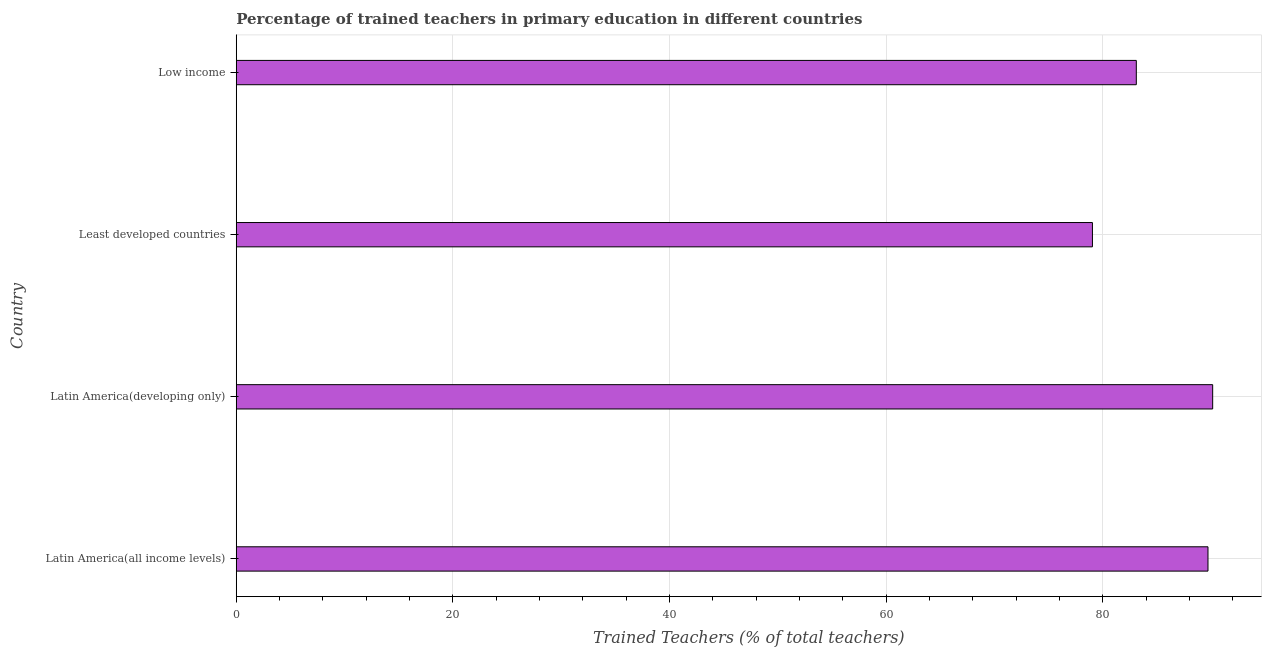Does the graph contain any zero values?
Provide a succinct answer. No. Does the graph contain grids?
Offer a terse response. Yes. What is the title of the graph?
Your answer should be very brief. Percentage of trained teachers in primary education in different countries. What is the label or title of the X-axis?
Your answer should be compact. Trained Teachers (% of total teachers). What is the percentage of trained teachers in Latin America(developing only)?
Keep it short and to the point. 90.13. Across all countries, what is the maximum percentage of trained teachers?
Provide a succinct answer. 90.13. Across all countries, what is the minimum percentage of trained teachers?
Your answer should be very brief. 79.03. In which country was the percentage of trained teachers maximum?
Provide a succinct answer. Latin America(developing only). In which country was the percentage of trained teachers minimum?
Offer a terse response. Least developed countries. What is the sum of the percentage of trained teachers?
Give a very brief answer. 341.94. What is the difference between the percentage of trained teachers in Latin America(developing only) and Least developed countries?
Ensure brevity in your answer.  11.1. What is the average percentage of trained teachers per country?
Provide a succinct answer. 85.48. What is the median percentage of trained teachers?
Your answer should be very brief. 86.39. In how many countries, is the percentage of trained teachers greater than 48 %?
Offer a terse response. 4. What is the ratio of the percentage of trained teachers in Least developed countries to that in Low income?
Offer a terse response. 0.95. What is the difference between the highest and the second highest percentage of trained teachers?
Ensure brevity in your answer.  0.43. Is the sum of the percentage of trained teachers in Latin America(all income levels) and Least developed countries greater than the maximum percentage of trained teachers across all countries?
Your answer should be very brief. Yes. What is the difference between the highest and the lowest percentage of trained teachers?
Offer a very short reply. 11.1. How many bars are there?
Provide a short and direct response. 4. Are all the bars in the graph horizontal?
Offer a terse response. Yes. How many countries are there in the graph?
Give a very brief answer. 4. What is the difference between two consecutive major ticks on the X-axis?
Ensure brevity in your answer.  20. Are the values on the major ticks of X-axis written in scientific E-notation?
Make the answer very short. No. What is the Trained Teachers (% of total teachers) of Latin America(all income levels)?
Provide a short and direct response. 89.7. What is the Trained Teachers (% of total teachers) in Latin America(developing only)?
Ensure brevity in your answer.  90.13. What is the Trained Teachers (% of total teachers) in Least developed countries?
Your answer should be very brief. 79.03. What is the Trained Teachers (% of total teachers) of Low income?
Keep it short and to the point. 83.08. What is the difference between the Trained Teachers (% of total teachers) in Latin America(all income levels) and Latin America(developing only)?
Make the answer very short. -0.43. What is the difference between the Trained Teachers (% of total teachers) in Latin America(all income levels) and Least developed countries?
Keep it short and to the point. 10.67. What is the difference between the Trained Teachers (% of total teachers) in Latin America(all income levels) and Low income?
Your response must be concise. 6.62. What is the difference between the Trained Teachers (% of total teachers) in Latin America(developing only) and Least developed countries?
Provide a succinct answer. 11.1. What is the difference between the Trained Teachers (% of total teachers) in Latin America(developing only) and Low income?
Your answer should be compact. 7.05. What is the difference between the Trained Teachers (% of total teachers) in Least developed countries and Low income?
Your answer should be very brief. -4.05. What is the ratio of the Trained Teachers (% of total teachers) in Latin America(all income levels) to that in Least developed countries?
Offer a terse response. 1.14. What is the ratio of the Trained Teachers (% of total teachers) in Latin America(all income levels) to that in Low income?
Provide a short and direct response. 1.08. What is the ratio of the Trained Teachers (% of total teachers) in Latin America(developing only) to that in Least developed countries?
Provide a succinct answer. 1.14. What is the ratio of the Trained Teachers (% of total teachers) in Latin America(developing only) to that in Low income?
Offer a very short reply. 1.08. What is the ratio of the Trained Teachers (% of total teachers) in Least developed countries to that in Low income?
Keep it short and to the point. 0.95. 